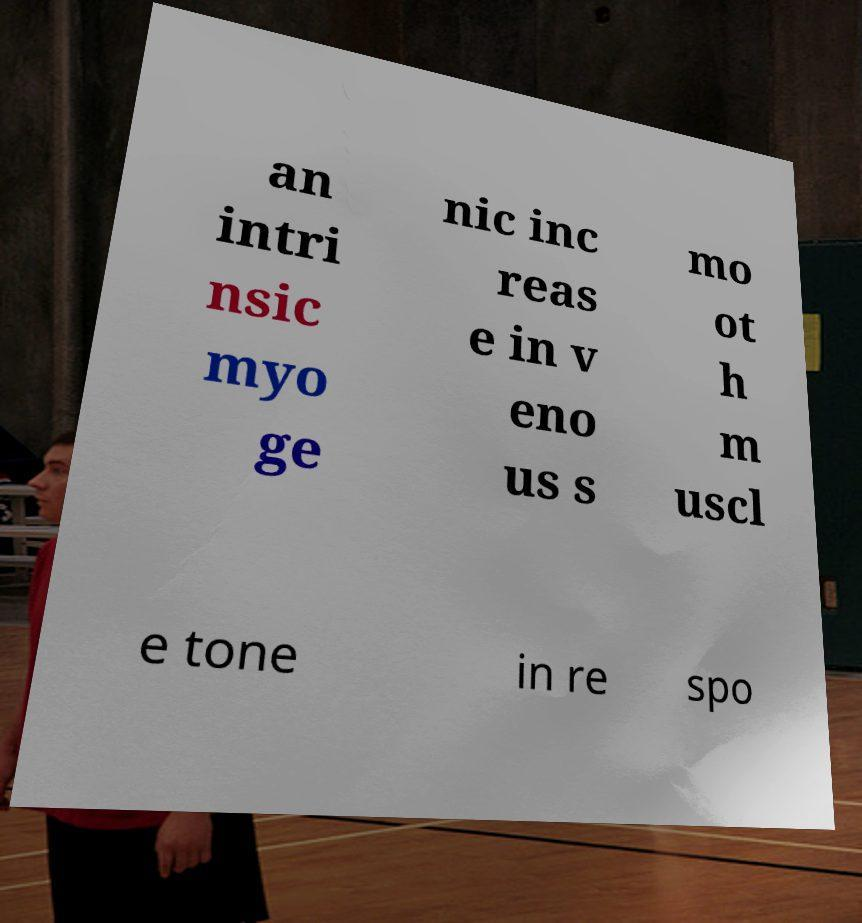Please identify and transcribe the text found in this image. an intri nsic myo ge nic inc reas e in v eno us s mo ot h m uscl e tone in re spo 